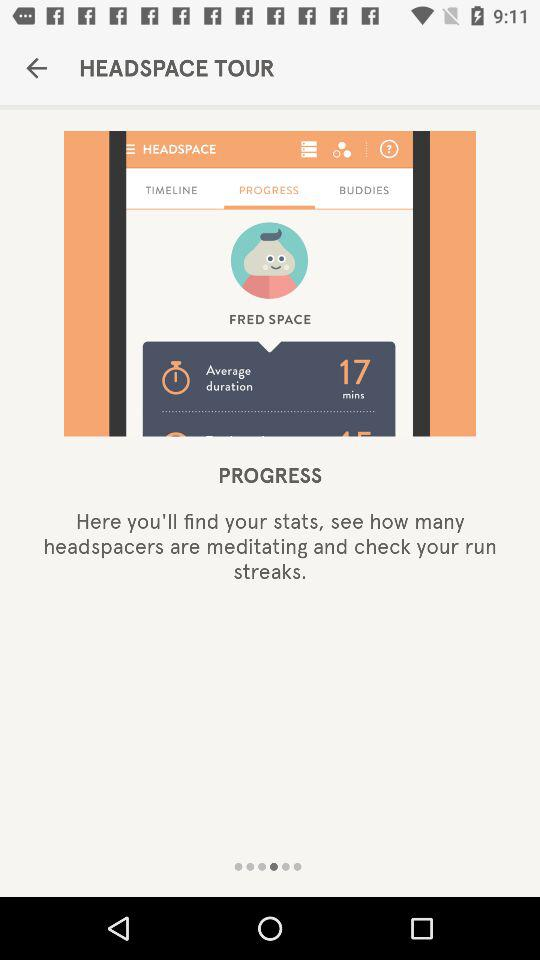Which tab is selected? The selected tab is "PROGRESS". 